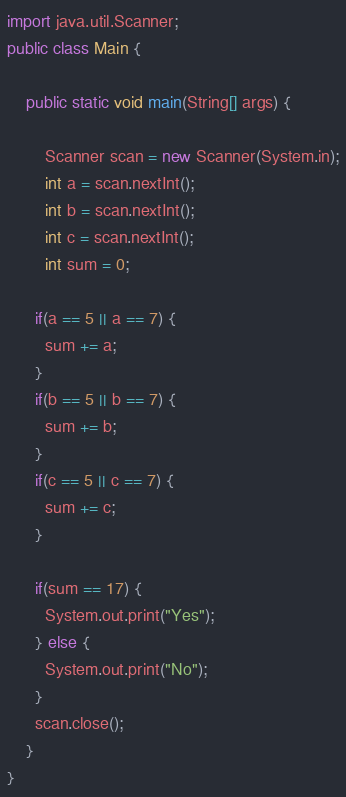<code> <loc_0><loc_0><loc_500><loc_500><_Java_>import java.util.Scanner;
public class Main {

	public static void main(String[] args) {
		
		Scanner scan = new Scanner(System.in);
		int a = scan.nextInt();
		int b = scan.nextInt();
		int c = scan.nextInt();
      	int sum = 0;
      
      if(a == 5 || a == 7) {
      	sum += a;
      }
      if(b == 5 || b == 7) {
      	sum += b;
      }
      if(c == 5 || c == 7) {
      	sum += c;
      }
      
      if(sum == 17) {
      	System.out.print("Yes");
      } else {
      	System.out.print("No");
      }
      scan.close();
	}
}</code> 